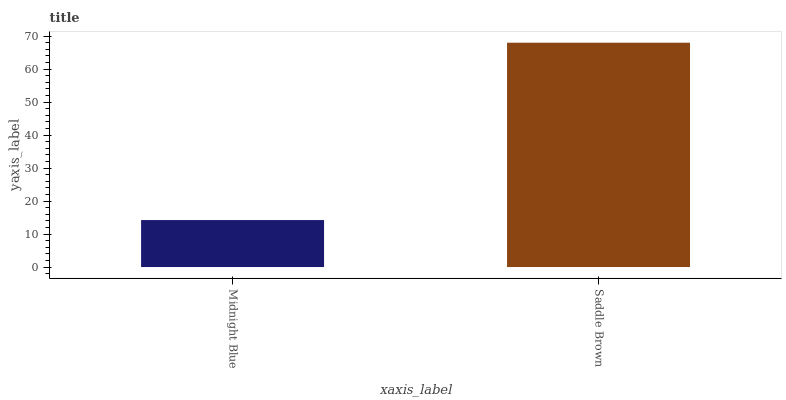Is Midnight Blue the minimum?
Answer yes or no. Yes. Is Saddle Brown the maximum?
Answer yes or no. Yes. Is Saddle Brown the minimum?
Answer yes or no. No. Is Saddle Brown greater than Midnight Blue?
Answer yes or no. Yes. Is Midnight Blue less than Saddle Brown?
Answer yes or no. Yes. Is Midnight Blue greater than Saddle Brown?
Answer yes or no. No. Is Saddle Brown less than Midnight Blue?
Answer yes or no. No. Is Saddle Brown the high median?
Answer yes or no. Yes. Is Midnight Blue the low median?
Answer yes or no. Yes. Is Midnight Blue the high median?
Answer yes or no. No. Is Saddle Brown the low median?
Answer yes or no. No. 